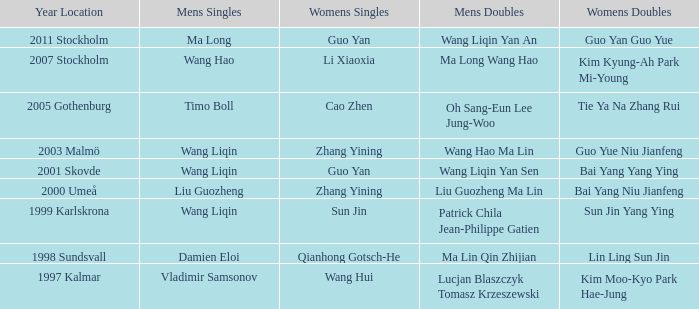What is the place and when was the year when the women's doubles womens were Bai yang Niu Jianfeng? 2000 Umeå. 